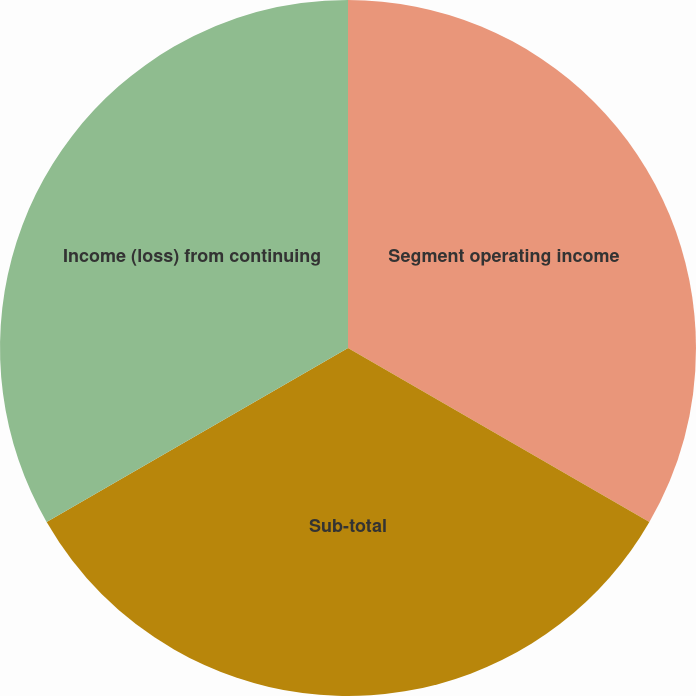<chart> <loc_0><loc_0><loc_500><loc_500><pie_chart><fcel>Segment operating income<fcel>Sub-total<fcel>Income (loss) from continuing<nl><fcel>33.33%<fcel>33.33%<fcel>33.33%<nl></chart> 